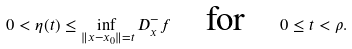Convert formula to latex. <formula><loc_0><loc_0><loc_500><loc_500>0 < \eta ( t ) \leq \inf _ { \| x - x _ { 0 } \| = t } D _ { x } ^ { - } f \quad \text {for} \quad 0 \leq t < \rho .</formula> 